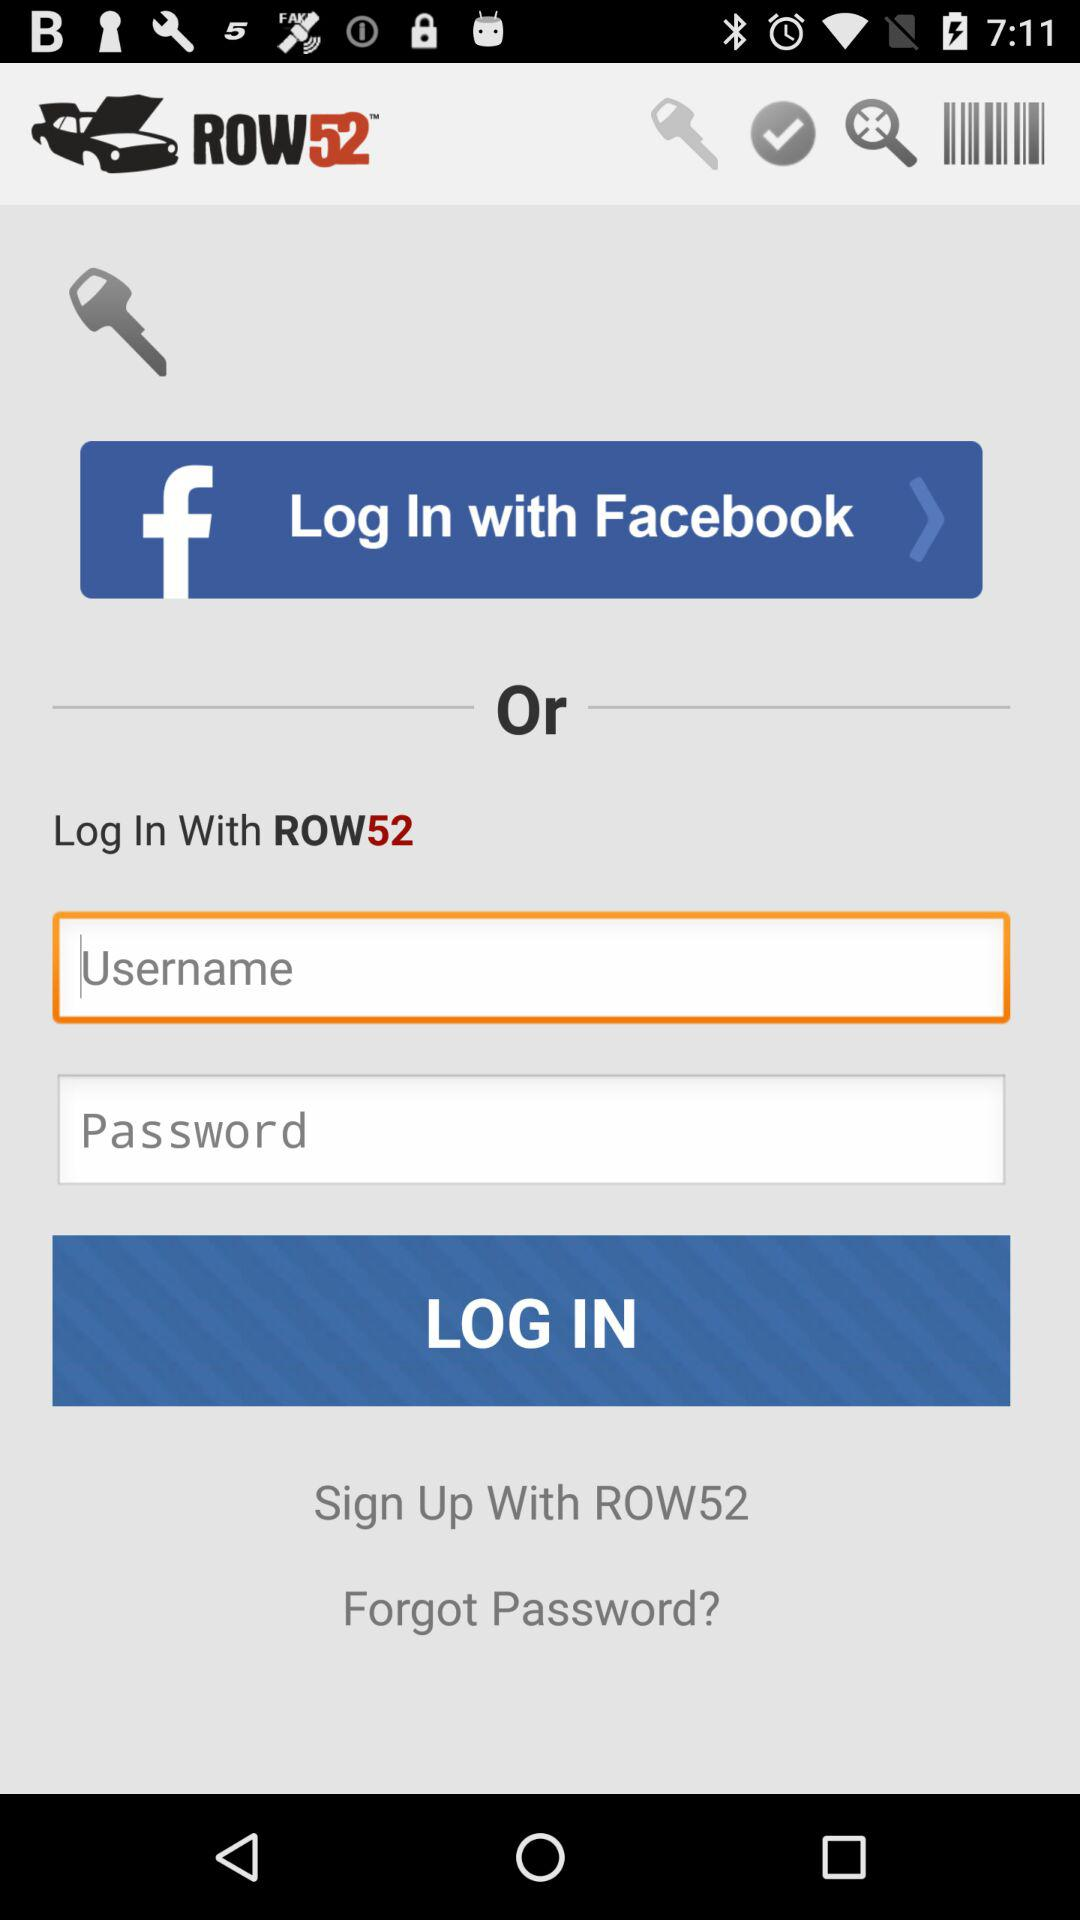What are the different options available for log in? The available options are: "Facebook" and "ROW52". 